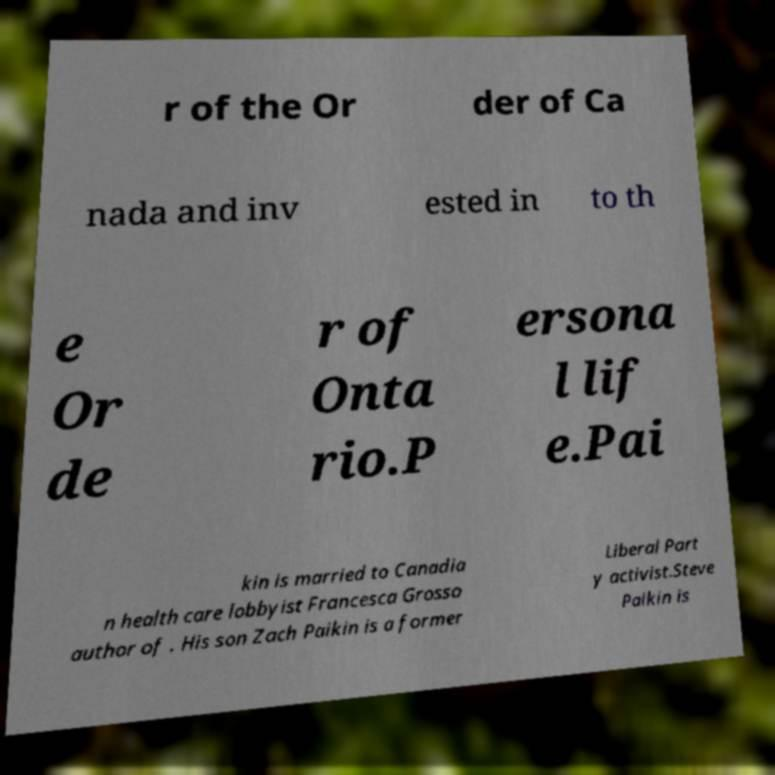I need the written content from this picture converted into text. Can you do that? r of the Or der of Ca nada and inv ested in to th e Or de r of Onta rio.P ersona l lif e.Pai kin is married to Canadia n health care lobbyist Francesca Grosso author of . His son Zach Paikin is a former Liberal Part y activist.Steve Paikin is 